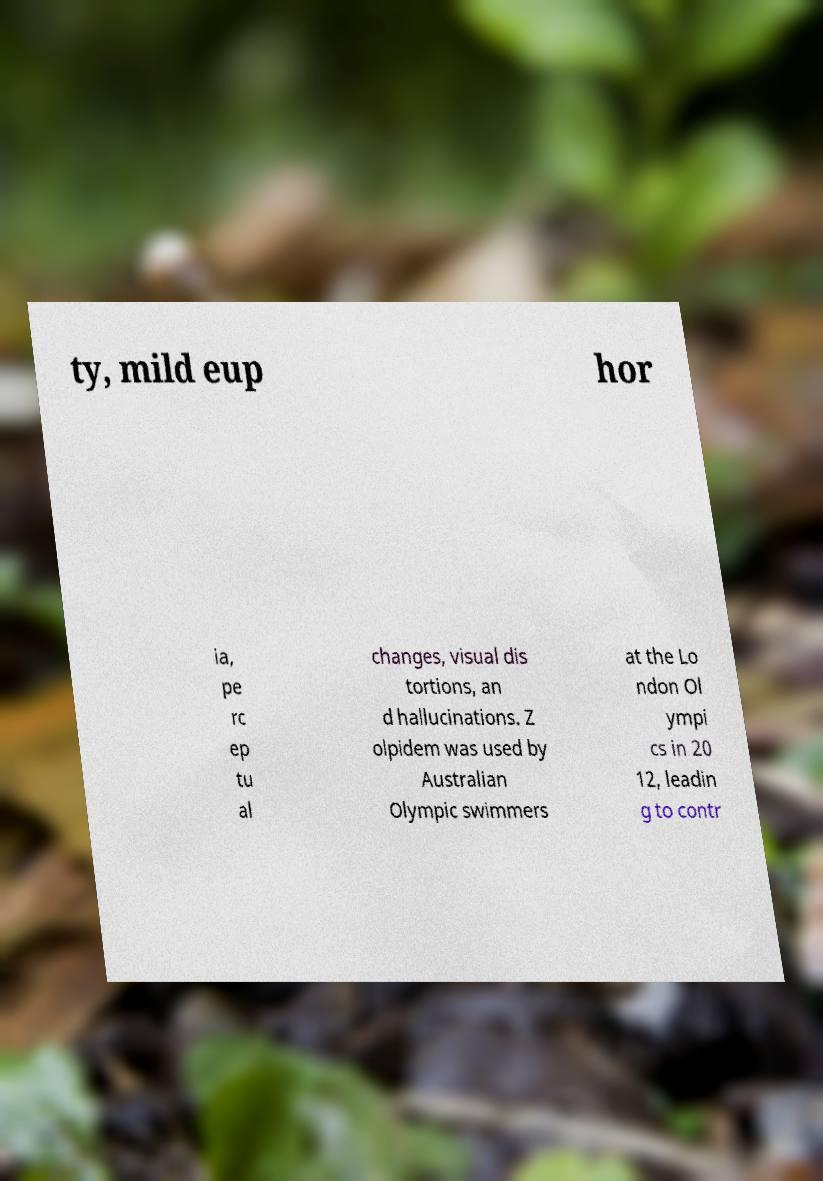There's text embedded in this image that I need extracted. Can you transcribe it verbatim? ty, mild eup hor ia, pe rc ep tu al changes, visual dis tortions, an d hallucinations. Z olpidem was used by Australian Olympic swimmers at the Lo ndon Ol ympi cs in 20 12, leadin g to contr 